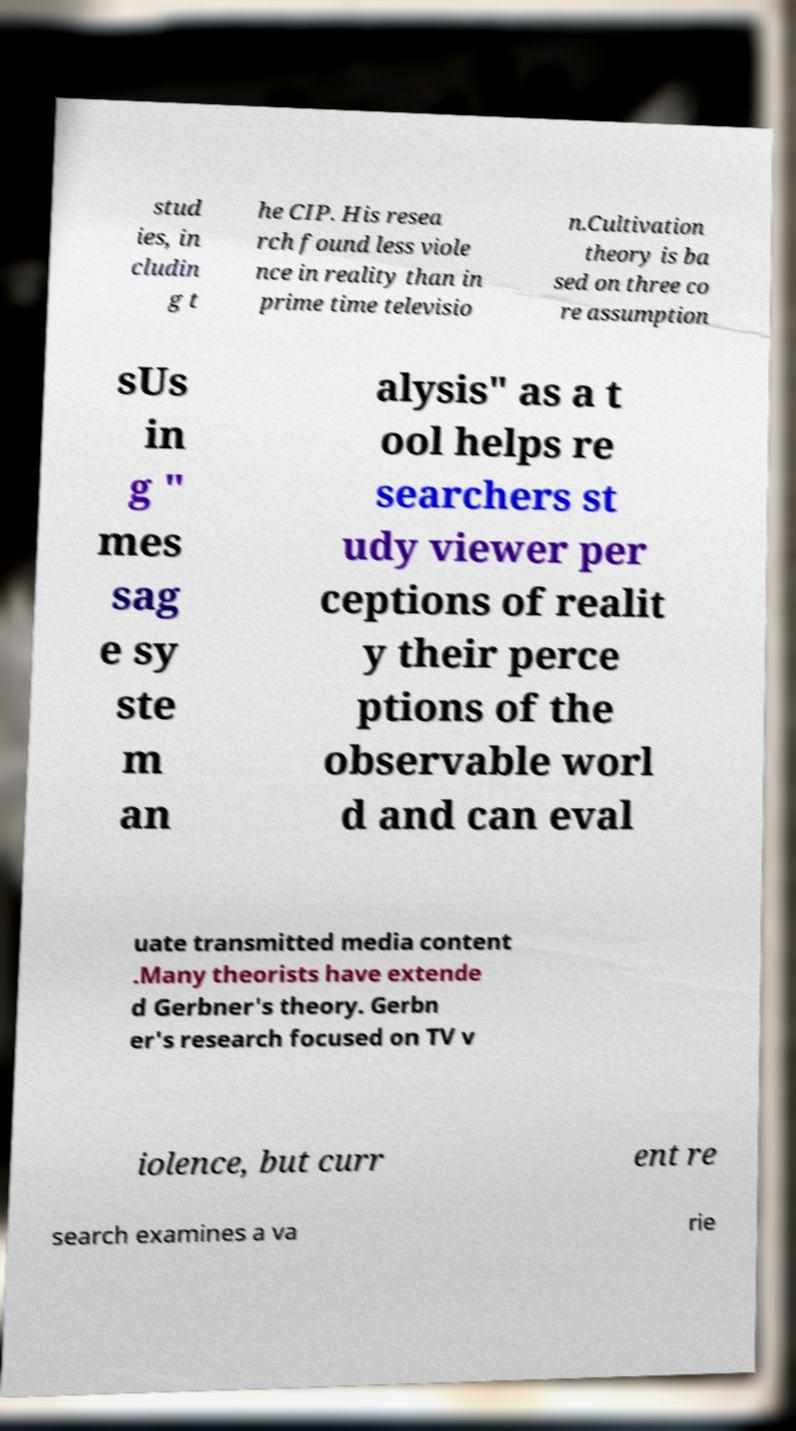Can you read and provide the text displayed in the image?This photo seems to have some interesting text. Can you extract and type it out for me? stud ies, in cludin g t he CIP. His resea rch found less viole nce in reality than in prime time televisio n.Cultivation theory is ba sed on three co re assumption sUs in g " mes sag e sy ste m an alysis" as a t ool helps re searchers st udy viewer per ceptions of realit y their perce ptions of the observable worl d and can eval uate transmitted media content .Many theorists have extende d Gerbner's theory. Gerbn er's research focused on TV v iolence, but curr ent re search examines a va rie 